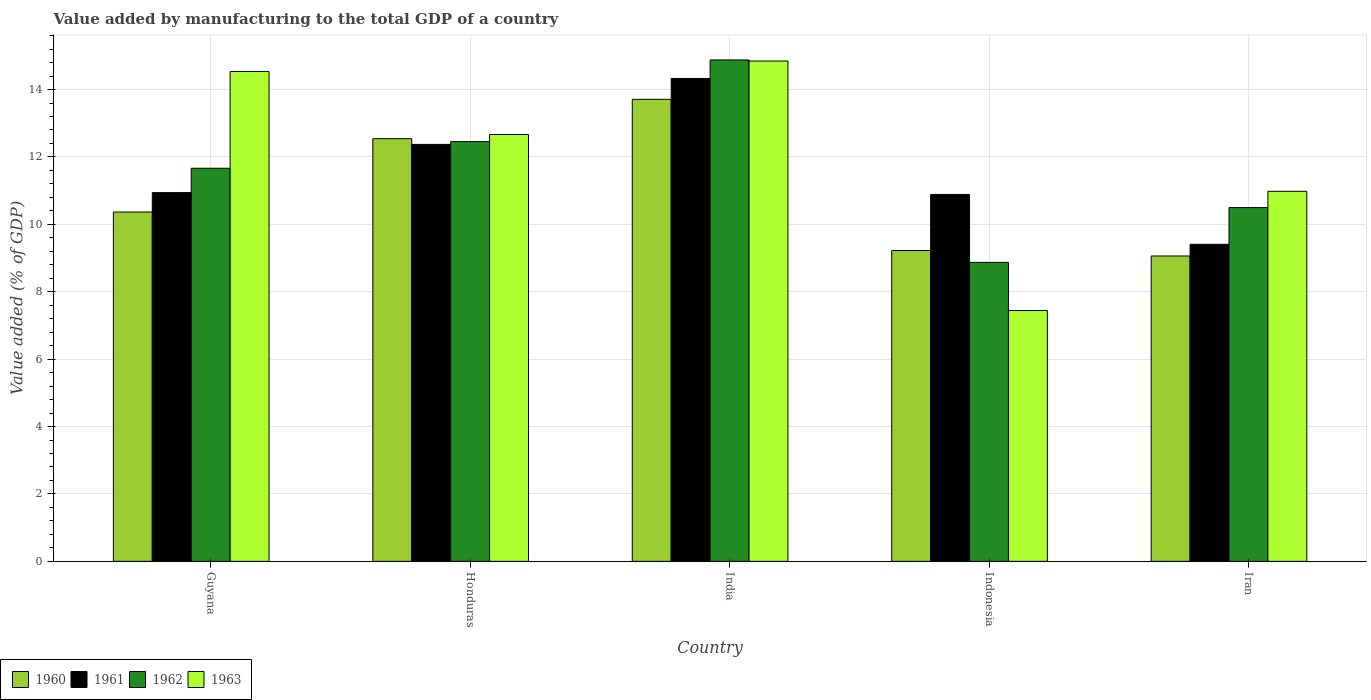Are the number of bars per tick equal to the number of legend labels?
Your answer should be compact. Yes. Are the number of bars on each tick of the X-axis equal?
Offer a terse response. Yes. How many bars are there on the 5th tick from the left?
Your response must be concise. 4. What is the label of the 2nd group of bars from the left?
Keep it short and to the point. Honduras. What is the value added by manufacturing to the total GDP in 1962 in India?
Offer a terse response. 14.88. Across all countries, what is the maximum value added by manufacturing to the total GDP in 1963?
Give a very brief answer. 14.85. Across all countries, what is the minimum value added by manufacturing to the total GDP in 1961?
Provide a short and direct response. 9.41. In which country was the value added by manufacturing to the total GDP in 1961 minimum?
Ensure brevity in your answer.  Iran. What is the total value added by manufacturing to the total GDP in 1962 in the graph?
Provide a short and direct response. 58.37. What is the difference between the value added by manufacturing to the total GDP in 1963 in Honduras and that in Indonesia?
Provide a short and direct response. 5.22. What is the difference between the value added by manufacturing to the total GDP in 1962 in Indonesia and the value added by manufacturing to the total GDP in 1960 in Guyana?
Make the answer very short. -1.49. What is the average value added by manufacturing to the total GDP in 1960 per country?
Make the answer very short. 10.98. What is the difference between the value added by manufacturing to the total GDP of/in 1960 and value added by manufacturing to the total GDP of/in 1961 in Guyana?
Provide a short and direct response. -0.58. In how many countries, is the value added by manufacturing to the total GDP in 1960 greater than 12.4 %?
Give a very brief answer. 2. What is the ratio of the value added by manufacturing to the total GDP in 1961 in Guyana to that in Indonesia?
Your answer should be very brief. 1. What is the difference between the highest and the second highest value added by manufacturing to the total GDP in 1963?
Give a very brief answer. -2.18. What is the difference between the highest and the lowest value added by manufacturing to the total GDP in 1963?
Offer a terse response. 7.4. In how many countries, is the value added by manufacturing to the total GDP in 1963 greater than the average value added by manufacturing to the total GDP in 1963 taken over all countries?
Offer a terse response. 3. Is the sum of the value added by manufacturing to the total GDP in 1961 in Guyana and Iran greater than the maximum value added by manufacturing to the total GDP in 1960 across all countries?
Offer a terse response. Yes. Is it the case that in every country, the sum of the value added by manufacturing to the total GDP in 1963 and value added by manufacturing to the total GDP in 1960 is greater than the sum of value added by manufacturing to the total GDP in 1962 and value added by manufacturing to the total GDP in 1961?
Offer a very short reply. No. What does the 4th bar from the left in India represents?
Offer a very short reply. 1963. Is it the case that in every country, the sum of the value added by manufacturing to the total GDP in 1960 and value added by manufacturing to the total GDP in 1962 is greater than the value added by manufacturing to the total GDP in 1963?
Keep it short and to the point. Yes. How many bars are there?
Your answer should be compact. 20. Are all the bars in the graph horizontal?
Keep it short and to the point. No. What is the title of the graph?
Give a very brief answer. Value added by manufacturing to the total GDP of a country. Does "1962" appear as one of the legend labels in the graph?
Your answer should be compact. Yes. What is the label or title of the Y-axis?
Offer a very short reply. Value added (% of GDP). What is the Value added (% of GDP) of 1960 in Guyana?
Offer a very short reply. 10.37. What is the Value added (% of GDP) of 1961 in Guyana?
Make the answer very short. 10.94. What is the Value added (% of GDP) in 1962 in Guyana?
Your response must be concise. 11.66. What is the Value added (% of GDP) in 1963 in Guyana?
Provide a succinct answer. 14.54. What is the Value added (% of GDP) of 1960 in Honduras?
Make the answer very short. 12.54. What is the Value added (% of GDP) of 1961 in Honduras?
Give a very brief answer. 12.37. What is the Value added (% of GDP) of 1962 in Honduras?
Make the answer very short. 12.45. What is the Value added (% of GDP) in 1963 in Honduras?
Keep it short and to the point. 12.67. What is the Value added (% of GDP) of 1960 in India?
Offer a terse response. 13.71. What is the Value added (% of GDP) in 1961 in India?
Keep it short and to the point. 14.33. What is the Value added (% of GDP) in 1962 in India?
Make the answer very short. 14.88. What is the Value added (% of GDP) in 1963 in India?
Your answer should be very brief. 14.85. What is the Value added (% of GDP) of 1960 in Indonesia?
Ensure brevity in your answer.  9.22. What is the Value added (% of GDP) in 1961 in Indonesia?
Your answer should be compact. 10.89. What is the Value added (% of GDP) of 1962 in Indonesia?
Provide a short and direct response. 8.87. What is the Value added (% of GDP) in 1963 in Indonesia?
Offer a very short reply. 7.44. What is the Value added (% of GDP) in 1960 in Iran?
Your answer should be very brief. 9.06. What is the Value added (% of GDP) of 1961 in Iran?
Your response must be concise. 9.41. What is the Value added (% of GDP) in 1962 in Iran?
Make the answer very short. 10.5. What is the Value added (% of GDP) in 1963 in Iran?
Offer a terse response. 10.98. Across all countries, what is the maximum Value added (% of GDP) in 1960?
Make the answer very short. 13.71. Across all countries, what is the maximum Value added (% of GDP) in 1961?
Offer a terse response. 14.33. Across all countries, what is the maximum Value added (% of GDP) in 1962?
Offer a terse response. 14.88. Across all countries, what is the maximum Value added (% of GDP) in 1963?
Keep it short and to the point. 14.85. Across all countries, what is the minimum Value added (% of GDP) of 1960?
Your answer should be compact. 9.06. Across all countries, what is the minimum Value added (% of GDP) in 1961?
Ensure brevity in your answer.  9.41. Across all countries, what is the minimum Value added (% of GDP) of 1962?
Ensure brevity in your answer.  8.87. Across all countries, what is the minimum Value added (% of GDP) in 1963?
Provide a short and direct response. 7.44. What is the total Value added (% of GDP) in 1960 in the graph?
Keep it short and to the point. 54.9. What is the total Value added (% of GDP) in 1961 in the graph?
Make the answer very short. 57.94. What is the total Value added (% of GDP) in 1962 in the graph?
Your answer should be compact. 58.37. What is the total Value added (% of GDP) in 1963 in the graph?
Offer a terse response. 60.47. What is the difference between the Value added (% of GDP) of 1960 in Guyana and that in Honduras?
Provide a succinct answer. -2.18. What is the difference between the Value added (% of GDP) in 1961 in Guyana and that in Honduras?
Your response must be concise. -1.43. What is the difference between the Value added (% of GDP) in 1962 in Guyana and that in Honduras?
Give a very brief answer. -0.79. What is the difference between the Value added (% of GDP) of 1963 in Guyana and that in Honduras?
Offer a terse response. 1.87. What is the difference between the Value added (% of GDP) of 1960 in Guyana and that in India?
Offer a terse response. -3.34. What is the difference between the Value added (% of GDP) in 1961 in Guyana and that in India?
Your answer should be very brief. -3.39. What is the difference between the Value added (% of GDP) of 1962 in Guyana and that in India?
Offer a terse response. -3.21. What is the difference between the Value added (% of GDP) of 1963 in Guyana and that in India?
Your response must be concise. -0.31. What is the difference between the Value added (% of GDP) in 1960 in Guyana and that in Indonesia?
Keep it short and to the point. 1.14. What is the difference between the Value added (% of GDP) in 1961 in Guyana and that in Indonesia?
Your response must be concise. 0.05. What is the difference between the Value added (% of GDP) of 1962 in Guyana and that in Indonesia?
Your response must be concise. 2.79. What is the difference between the Value added (% of GDP) of 1963 in Guyana and that in Indonesia?
Your answer should be compact. 7.09. What is the difference between the Value added (% of GDP) in 1960 in Guyana and that in Iran?
Provide a succinct answer. 1.3. What is the difference between the Value added (% of GDP) in 1961 in Guyana and that in Iran?
Offer a very short reply. 1.53. What is the difference between the Value added (% of GDP) in 1962 in Guyana and that in Iran?
Your answer should be compact. 1.17. What is the difference between the Value added (% of GDP) in 1963 in Guyana and that in Iran?
Offer a very short reply. 3.56. What is the difference between the Value added (% of GDP) of 1960 in Honduras and that in India?
Your answer should be compact. -1.17. What is the difference between the Value added (% of GDP) of 1961 in Honduras and that in India?
Your response must be concise. -1.96. What is the difference between the Value added (% of GDP) of 1962 in Honduras and that in India?
Your answer should be compact. -2.42. What is the difference between the Value added (% of GDP) in 1963 in Honduras and that in India?
Keep it short and to the point. -2.18. What is the difference between the Value added (% of GDP) of 1960 in Honduras and that in Indonesia?
Offer a terse response. 3.32. What is the difference between the Value added (% of GDP) of 1961 in Honduras and that in Indonesia?
Your response must be concise. 1.49. What is the difference between the Value added (% of GDP) of 1962 in Honduras and that in Indonesia?
Your response must be concise. 3.58. What is the difference between the Value added (% of GDP) of 1963 in Honduras and that in Indonesia?
Make the answer very short. 5.22. What is the difference between the Value added (% of GDP) in 1960 in Honduras and that in Iran?
Ensure brevity in your answer.  3.48. What is the difference between the Value added (% of GDP) in 1961 in Honduras and that in Iran?
Provide a succinct answer. 2.96. What is the difference between the Value added (% of GDP) in 1962 in Honduras and that in Iran?
Your answer should be very brief. 1.96. What is the difference between the Value added (% of GDP) of 1963 in Honduras and that in Iran?
Your response must be concise. 1.69. What is the difference between the Value added (% of GDP) of 1960 in India and that in Indonesia?
Ensure brevity in your answer.  4.49. What is the difference between the Value added (% of GDP) in 1961 in India and that in Indonesia?
Provide a short and direct response. 3.44. What is the difference between the Value added (% of GDP) of 1962 in India and that in Indonesia?
Keep it short and to the point. 6.01. What is the difference between the Value added (% of GDP) in 1963 in India and that in Indonesia?
Provide a succinct answer. 7.4. What is the difference between the Value added (% of GDP) of 1960 in India and that in Iran?
Offer a very short reply. 4.65. What is the difference between the Value added (% of GDP) of 1961 in India and that in Iran?
Give a very brief answer. 4.92. What is the difference between the Value added (% of GDP) in 1962 in India and that in Iran?
Provide a short and direct response. 4.38. What is the difference between the Value added (% of GDP) in 1963 in India and that in Iran?
Provide a succinct answer. 3.87. What is the difference between the Value added (% of GDP) in 1960 in Indonesia and that in Iran?
Provide a short and direct response. 0.16. What is the difference between the Value added (% of GDP) in 1961 in Indonesia and that in Iran?
Your answer should be compact. 1.48. What is the difference between the Value added (% of GDP) in 1962 in Indonesia and that in Iran?
Ensure brevity in your answer.  -1.63. What is the difference between the Value added (% of GDP) in 1963 in Indonesia and that in Iran?
Your response must be concise. -3.54. What is the difference between the Value added (% of GDP) in 1960 in Guyana and the Value added (% of GDP) in 1961 in Honduras?
Your response must be concise. -2.01. What is the difference between the Value added (% of GDP) of 1960 in Guyana and the Value added (% of GDP) of 1962 in Honduras?
Offer a terse response. -2.09. What is the difference between the Value added (% of GDP) of 1960 in Guyana and the Value added (% of GDP) of 1963 in Honduras?
Provide a short and direct response. -2.3. What is the difference between the Value added (% of GDP) in 1961 in Guyana and the Value added (% of GDP) in 1962 in Honduras?
Your answer should be compact. -1.51. What is the difference between the Value added (% of GDP) of 1961 in Guyana and the Value added (% of GDP) of 1963 in Honduras?
Provide a short and direct response. -1.73. What is the difference between the Value added (% of GDP) in 1962 in Guyana and the Value added (% of GDP) in 1963 in Honduras?
Your answer should be compact. -1. What is the difference between the Value added (% of GDP) in 1960 in Guyana and the Value added (% of GDP) in 1961 in India?
Your answer should be compact. -3.96. What is the difference between the Value added (% of GDP) in 1960 in Guyana and the Value added (% of GDP) in 1962 in India?
Give a very brief answer. -4.51. What is the difference between the Value added (% of GDP) of 1960 in Guyana and the Value added (% of GDP) of 1963 in India?
Give a very brief answer. -4.48. What is the difference between the Value added (% of GDP) in 1961 in Guyana and the Value added (% of GDP) in 1962 in India?
Provide a succinct answer. -3.94. What is the difference between the Value added (% of GDP) of 1961 in Guyana and the Value added (% of GDP) of 1963 in India?
Your answer should be compact. -3.91. What is the difference between the Value added (% of GDP) of 1962 in Guyana and the Value added (% of GDP) of 1963 in India?
Give a very brief answer. -3.18. What is the difference between the Value added (% of GDP) of 1960 in Guyana and the Value added (% of GDP) of 1961 in Indonesia?
Your response must be concise. -0.52. What is the difference between the Value added (% of GDP) of 1960 in Guyana and the Value added (% of GDP) of 1962 in Indonesia?
Your response must be concise. 1.49. What is the difference between the Value added (% of GDP) of 1960 in Guyana and the Value added (% of GDP) of 1963 in Indonesia?
Offer a very short reply. 2.92. What is the difference between the Value added (% of GDP) in 1961 in Guyana and the Value added (% of GDP) in 1962 in Indonesia?
Provide a short and direct response. 2.07. What is the difference between the Value added (% of GDP) in 1961 in Guyana and the Value added (% of GDP) in 1963 in Indonesia?
Provide a short and direct response. 3.5. What is the difference between the Value added (% of GDP) of 1962 in Guyana and the Value added (% of GDP) of 1963 in Indonesia?
Your response must be concise. 4.22. What is the difference between the Value added (% of GDP) of 1960 in Guyana and the Value added (% of GDP) of 1961 in Iran?
Provide a short and direct response. 0.96. What is the difference between the Value added (% of GDP) of 1960 in Guyana and the Value added (% of GDP) of 1962 in Iran?
Provide a short and direct response. -0.13. What is the difference between the Value added (% of GDP) of 1960 in Guyana and the Value added (% of GDP) of 1963 in Iran?
Make the answer very short. -0.61. What is the difference between the Value added (% of GDP) in 1961 in Guyana and the Value added (% of GDP) in 1962 in Iran?
Your response must be concise. 0.44. What is the difference between the Value added (% of GDP) of 1961 in Guyana and the Value added (% of GDP) of 1963 in Iran?
Make the answer very short. -0.04. What is the difference between the Value added (% of GDP) of 1962 in Guyana and the Value added (% of GDP) of 1963 in Iran?
Keep it short and to the point. 0.68. What is the difference between the Value added (% of GDP) in 1960 in Honduras and the Value added (% of GDP) in 1961 in India?
Provide a short and direct response. -1.79. What is the difference between the Value added (% of GDP) of 1960 in Honduras and the Value added (% of GDP) of 1962 in India?
Offer a terse response. -2.34. What is the difference between the Value added (% of GDP) in 1960 in Honduras and the Value added (% of GDP) in 1963 in India?
Keep it short and to the point. -2.31. What is the difference between the Value added (% of GDP) in 1961 in Honduras and the Value added (% of GDP) in 1962 in India?
Give a very brief answer. -2.51. What is the difference between the Value added (% of GDP) of 1961 in Honduras and the Value added (% of GDP) of 1963 in India?
Ensure brevity in your answer.  -2.47. What is the difference between the Value added (% of GDP) of 1962 in Honduras and the Value added (% of GDP) of 1963 in India?
Your response must be concise. -2.39. What is the difference between the Value added (% of GDP) of 1960 in Honduras and the Value added (% of GDP) of 1961 in Indonesia?
Offer a terse response. 1.65. What is the difference between the Value added (% of GDP) in 1960 in Honduras and the Value added (% of GDP) in 1962 in Indonesia?
Offer a very short reply. 3.67. What is the difference between the Value added (% of GDP) of 1960 in Honduras and the Value added (% of GDP) of 1963 in Indonesia?
Offer a terse response. 5.1. What is the difference between the Value added (% of GDP) of 1961 in Honduras and the Value added (% of GDP) of 1962 in Indonesia?
Your answer should be compact. 3.5. What is the difference between the Value added (% of GDP) in 1961 in Honduras and the Value added (% of GDP) in 1963 in Indonesia?
Offer a terse response. 4.93. What is the difference between the Value added (% of GDP) of 1962 in Honduras and the Value added (% of GDP) of 1963 in Indonesia?
Make the answer very short. 5.01. What is the difference between the Value added (% of GDP) in 1960 in Honduras and the Value added (% of GDP) in 1961 in Iran?
Your response must be concise. 3.13. What is the difference between the Value added (% of GDP) in 1960 in Honduras and the Value added (% of GDP) in 1962 in Iran?
Offer a very short reply. 2.04. What is the difference between the Value added (% of GDP) in 1960 in Honduras and the Value added (% of GDP) in 1963 in Iran?
Provide a succinct answer. 1.56. What is the difference between the Value added (% of GDP) in 1961 in Honduras and the Value added (% of GDP) in 1962 in Iran?
Give a very brief answer. 1.88. What is the difference between the Value added (% of GDP) in 1961 in Honduras and the Value added (% of GDP) in 1963 in Iran?
Ensure brevity in your answer.  1.39. What is the difference between the Value added (% of GDP) in 1962 in Honduras and the Value added (% of GDP) in 1963 in Iran?
Give a very brief answer. 1.47. What is the difference between the Value added (% of GDP) in 1960 in India and the Value added (% of GDP) in 1961 in Indonesia?
Keep it short and to the point. 2.82. What is the difference between the Value added (% of GDP) in 1960 in India and the Value added (% of GDP) in 1962 in Indonesia?
Offer a very short reply. 4.84. What is the difference between the Value added (% of GDP) of 1960 in India and the Value added (% of GDP) of 1963 in Indonesia?
Keep it short and to the point. 6.27. What is the difference between the Value added (% of GDP) in 1961 in India and the Value added (% of GDP) in 1962 in Indonesia?
Provide a succinct answer. 5.46. What is the difference between the Value added (% of GDP) of 1961 in India and the Value added (% of GDP) of 1963 in Indonesia?
Keep it short and to the point. 6.89. What is the difference between the Value added (% of GDP) in 1962 in India and the Value added (% of GDP) in 1963 in Indonesia?
Offer a terse response. 7.44. What is the difference between the Value added (% of GDP) in 1960 in India and the Value added (% of GDP) in 1961 in Iran?
Provide a succinct answer. 4.3. What is the difference between the Value added (% of GDP) of 1960 in India and the Value added (% of GDP) of 1962 in Iran?
Your response must be concise. 3.21. What is the difference between the Value added (% of GDP) in 1960 in India and the Value added (% of GDP) in 1963 in Iran?
Offer a very short reply. 2.73. What is the difference between the Value added (% of GDP) of 1961 in India and the Value added (% of GDP) of 1962 in Iran?
Your answer should be very brief. 3.83. What is the difference between the Value added (% of GDP) of 1961 in India and the Value added (% of GDP) of 1963 in Iran?
Offer a very short reply. 3.35. What is the difference between the Value added (% of GDP) in 1962 in India and the Value added (% of GDP) in 1963 in Iran?
Your response must be concise. 3.9. What is the difference between the Value added (% of GDP) in 1960 in Indonesia and the Value added (% of GDP) in 1961 in Iran?
Make the answer very short. -0.18. What is the difference between the Value added (% of GDP) of 1960 in Indonesia and the Value added (% of GDP) of 1962 in Iran?
Give a very brief answer. -1.27. What is the difference between the Value added (% of GDP) of 1960 in Indonesia and the Value added (% of GDP) of 1963 in Iran?
Offer a terse response. -1.76. What is the difference between the Value added (% of GDP) of 1961 in Indonesia and the Value added (% of GDP) of 1962 in Iran?
Your response must be concise. 0.39. What is the difference between the Value added (% of GDP) in 1961 in Indonesia and the Value added (% of GDP) in 1963 in Iran?
Your answer should be compact. -0.09. What is the difference between the Value added (% of GDP) in 1962 in Indonesia and the Value added (% of GDP) in 1963 in Iran?
Your response must be concise. -2.11. What is the average Value added (% of GDP) of 1960 per country?
Make the answer very short. 10.98. What is the average Value added (% of GDP) in 1961 per country?
Give a very brief answer. 11.59. What is the average Value added (% of GDP) of 1962 per country?
Provide a short and direct response. 11.67. What is the average Value added (% of GDP) in 1963 per country?
Your response must be concise. 12.09. What is the difference between the Value added (% of GDP) in 1960 and Value added (% of GDP) in 1961 in Guyana?
Make the answer very short. -0.58. What is the difference between the Value added (% of GDP) in 1960 and Value added (% of GDP) in 1962 in Guyana?
Ensure brevity in your answer.  -1.3. What is the difference between the Value added (% of GDP) of 1960 and Value added (% of GDP) of 1963 in Guyana?
Give a very brief answer. -4.17. What is the difference between the Value added (% of GDP) of 1961 and Value added (% of GDP) of 1962 in Guyana?
Ensure brevity in your answer.  -0.72. What is the difference between the Value added (% of GDP) in 1961 and Value added (% of GDP) in 1963 in Guyana?
Make the answer very short. -3.6. What is the difference between the Value added (% of GDP) in 1962 and Value added (% of GDP) in 1963 in Guyana?
Give a very brief answer. -2.87. What is the difference between the Value added (% of GDP) in 1960 and Value added (% of GDP) in 1961 in Honduras?
Offer a very short reply. 0.17. What is the difference between the Value added (% of GDP) of 1960 and Value added (% of GDP) of 1962 in Honduras?
Make the answer very short. 0.09. What is the difference between the Value added (% of GDP) in 1960 and Value added (% of GDP) in 1963 in Honduras?
Make the answer very short. -0.13. What is the difference between the Value added (% of GDP) of 1961 and Value added (% of GDP) of 1962 in Honduras?
Make the answer very short. -0.08. What is the difference between the Value added (% of GDP) in 1961 and Value added (% of GDP) in 1963 in Honduras?
Keep it short and to the point. -0.29. What is the difference between the Value added (% of GDP) of 1962 and Value added (% of GDP) of 1963 in Honduras?
Ensure brevity in your answer.  -0.21. What is the difference between the Value added (% of GDP) in 1960 and Value added (% of GDP) in 1961 in India?
Give a very brief answer. -0.62. What is the difference between the Value added (% of GDP) in 1960 and Value added (% of GDP) in 1962 in India?
Your answer should be compact. -1.17. What is the difference between the Value added (% of GDP) of 1960 and Value added (% of GDP) of 1963 in India?
Ensure brevity in your answer.  -1.14. What is the difference between the Value added (% of GDP) in 1961 and Value added (% of GDP) in 1962 in India?
Give a very brief answer. -0.55. What is the difference between the Value added (% of GDP) in 1961 and Value added (% of GDP) in 1963 in India?
Offer a terse response. -0.52. What is the difference between the Value added (% of GDP) in 1962 and Value added (% of GDP) in 1963 in India?
Make the answer very short. 0.03. What is the difference between the Value added (% of GDP) in 1960 and Value added (% of GDP) in 1961 in Indonesia?
Offer a very short reply. -1.66. What is the difference between the Value added (% of GDP) in 1960 and Value added (% of GDP) in 1962 in Indonesia?
Keep it short and to the point. 0.35. What is the difference between the Value added (% of GDP) in 1960 and Value added (% of GDP) in 1963 in Indonesia?
Make the answer very short. 1.78. What is the difference between the Value added (% of GDP) of 1961 and Value added (% of GDP) of 1962 in Indonesia?
Your response must be concise. 2.02. What is the difference between the Value added (% of GDP) in 1961 and Value added (% of GDP) in 1963 in Indonesia?
Your answer should be compact. 3.44. What is the difference between the Value added (% of GDP) in 1962 and Value added (% of GDP) in 1963 in Indonesia?
Ensure brevity in your answer.  1.43. What is the difference between the Value added (% of GDP) of 1960 and Value added (% of GDP) of 1961 in Iran?
Provide a short and direct response. -0.35. What is the difference between the Value added (% of GDP) in 1960 and Value added (% of GDP) in 1962 in Iran?
Provide a short and direct response. -1.44. What is the difference between the Value added (% of GDP) of 1960 and Value added (% of GDP) of 1963 in Iran?
Make the answer very short. -1.92. What is the difference between the Value added (% of GDP) of 1961 and Value added (% of GDP) of 1962 in Iran?
Offer a terse response. -1.09. What is the difference between the Value added (% of GDP) of 1961 and Value added (% of GDP) of 1963 in Iran?
Ensure brevity in your answer.  -1.57. What is the difference between the Value added (% of GDP) in 1962 and Value added (% of GDP) in 1963 in Iran?
Give a very brief answer. -0.48. What is the ratio of the Value added (% of GDP) in 1960 in Guyana to that in Honduras?
Offer a very short reply. 0.83. What is the ratio of the Value added (% of GDP) in 1961 in Guyana to that in Honduras?
Offer a terse response. 0.88. What is the ratio of the Value added (% of GDP) in 1962 in Guyana to that in Honduras?
Provide a succinct answer. 0.94. What is the ratio of the Value added (% of GDP) of 1963 in Guyana to that in Honduras?
Offer a very short reply. 1.15. What is the ratio of the Value added (% of GDP) of 1960 in Guyana to that in India?
Your answer should be very brief. 0.76. What is the ratio of the Value added (% of GDP) of 1961 in Guyana to that in India?
Your response must be concise. 0.76. What is the ratio of the Value added (% of GDP) in 1962 in Guyana to that in India?
Offer a terse response. 0.78. What is the ratio of the Value added (% of GDP) of 1963 in Guyana to that in India?
Give a very brief answer. 0.98. What is the ratio of the Value added (% of GDP) in 1960 in Guyana to that in Indonesia?
Offer a terse response. 1.12. What is the ratio of the Value added (% of GDP) in 1961 in Guyana to that in Indonesia?
Provide a short and direct response. 1. What is the ratio of the Value added (% of GDP) of 1962 in Guyana to that in Indonesia?
Give a very brief answer. 1.31. What is the ratio of the Value added (% of GDP) of 1963 in Guyana to that in Indonesia?
Your response must be concise. 1.95. What is the ratio of the Value added (% of GDP) of 1960 in Guyana to that in Iran?
Your answer should be compact. 1.14. What is the ratio of the Value added (% of GDP) of 1961 in Guyana to that in Iran?
Give a very brief answer. 1.16. What is the ratio of the Value added (% of GDP) of 1962 in Guyana to that in Iran?
Give a very brief answer. 1.11. What is the ratio of the Value added (% of GDP) of 1963 in Guyana to that in Iran?
Offer a very short reply. 1.32. What is the ratio of the Value added (% of GDP) in 1960 in Honduras to that in India?
Keep it short and to the point. 0.91. What is the ratio of the Value added (% of GDP) of 1961 in Honduras to that in India?
Provide a succinct answer. 0.86. What is the ratio of the Value added (% of GDP) of 1962 in Honduras to that in India?
Offer a very short reply. 0.84. What is the ratio of the Value added (% of GDP) in 1963 in Honduras to that in India?
Offer a terse response. 0.85. What is the ratio of the Value added (% of GDP) in 1960 in Honduras to that in Indonesia?
Give a very brief answer. 1.36. What is the ratio of the Value added (% of GDP) of 1961 in Honduras to that in Indonesia?
Your answer should be compact. 1.14. What is the ratio of the Value added (% of GDP) in 1962 in Honduras to that in Indonesia?
Offer a very short reply. 1.4. What is the ratio of the Value added (% of GDP) in 1963 in Honduras to that in Indonesia?
Provide a succinct answer. 1.7. What is the ratio of the Value added (% of GDP) of 1960 in Honduras to that in Iran?
Offer a very short reply. 1.38. What is the ratio of the Value added (% of GDP) of 1961 in Honduras to that in Iran?
Your answer should be very brief. 1.32. What is the ratio of the Value added (% of GDP) of 1962 in Honduras to that in Iran?
Give a very brief answer. 1.19. What is the ratio of the Value added (% of GDP) of 1963 in Honduras to that in Iran?
Offer a very short reply. 1.15. What is the ratio of the Value added (% of GDP) in 1960 in India to that in Indonesia?
Your answer should be very brief. 1.49. What is the ratio of the Value added (% of GDP) in 1961 in India to that in Indonesia?
Keep it short and to the point. 1.32. What is the ratio of the Value added (% of GDP) of 1962 in India to that in Indonesia?
Give a very brief answer. 1.68. What is the ratio of the Value added (% of GDP) of 1963 in India to that in Indonesia?
Make the answer very short. 1.99. What is the ratio of the Value added (% of GDP) in 1960 in India to that in Iran?
Ensure brevity in your answer.  1.51. What is the ratio of the Value added (% of GDP) of 1961 in India to that in Iran?
Offer a very short reply. 1.52. What is the ratio of the Value added (% of GDP) of 1962 in India to that in Iran?
Your answer should be compact. 1.42. What is the ratio of the Value added (% of GDP) in 1963 in India to that in Iran?
Your response must be concise. 1.35. What is the ratio of the Value added (% of GDP) in 1960 in Indonesia to that in Iran?
Make the answer very short. 1.02. What is the ratio of the Value added (% of GDP) in 1961 in Indonesia to that in Iran?
Ensure brevity in your answer.  1.16. What is the ratio of the Value added (% of GDP) in 1962 in Indonesia to that in Iran?
Your answer should be compact. 0.85. What is the ratio of the Value added (% of GDP) in 1963 in Indonesia to that in Iran?
Your response must be concise. 0.68. What is the difference between the highest and the second highest Value added (% of GDP) in 1960?
Ensure brevity in your answer.  1.17. What is the difference between the highest and the second highest Value added (% of GDP) in 1961?
Ensure brevity in your answer.  1.96. What is the difference between the highest and the second highest Value added (% of GDP) in 1962?
Keep it short and to the point. 2.42. What is the difference between the highest and the second highest Value added (% of GDP) in 1963?
Provide a succinct answer. 0.31. What is the difference between the highest and the lowest Value added (% of GDP) of 1960?
Ensure brevity in your answer.  4.65. What is the difference between the highest and the lowest Value added (% of GDP) in 1961?
Your answer should be very brief. 4.92. What is the difference between the highest and the lowest Value added (% of GDP) of 1962?
Ensure brevity in your answer.  6.01. What is the difference between the highest and the lowest Value added (% of GDP) of 1963?
Give a very brief answer. 7.4. 